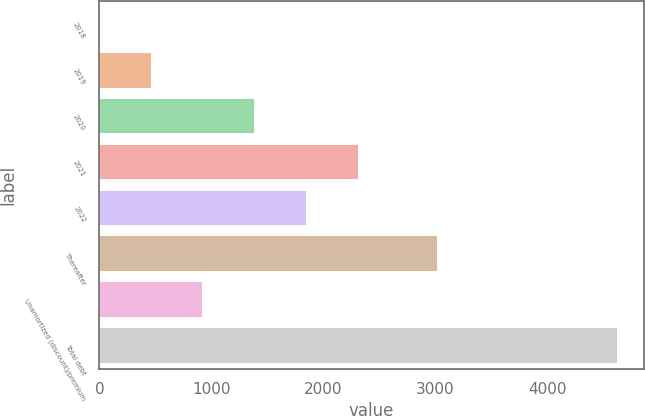Convert chart to OTSL. <chart><loc_0><loc_0><loc_500><loc_500><bar_chart><fcel>2018<fcel>2019<fcel>2020<fcel>2021<fcel>2022<fcel>Thereafter<fcel>Unamortized (discount)/premium<fcel>Total debt<nl><fcel>5<fcel>467.5<fcel>1392.5<fcel>2317.5<fcel>1855<fcel>3024<fcel>930<fcel>4630<nl></chart> 